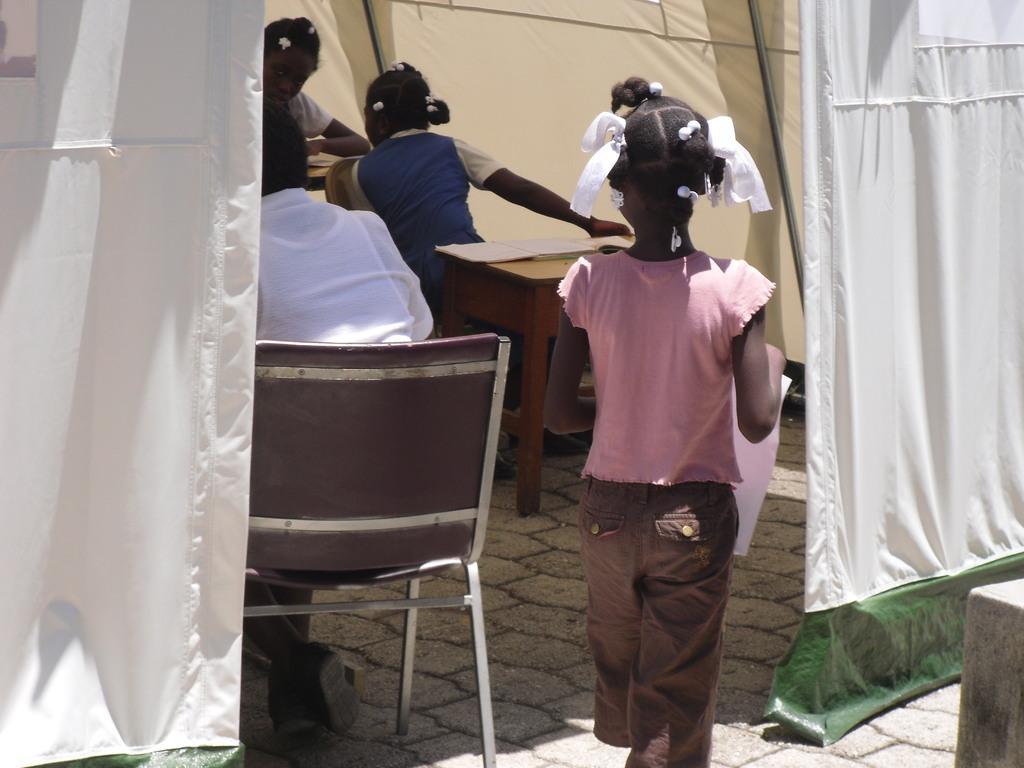How would you summarize this image in a sentence or two? In this picture there is a girl standing and holding a paper in her hand. There are other girls. There is a table, chair. There is a person sitting on the chair. 